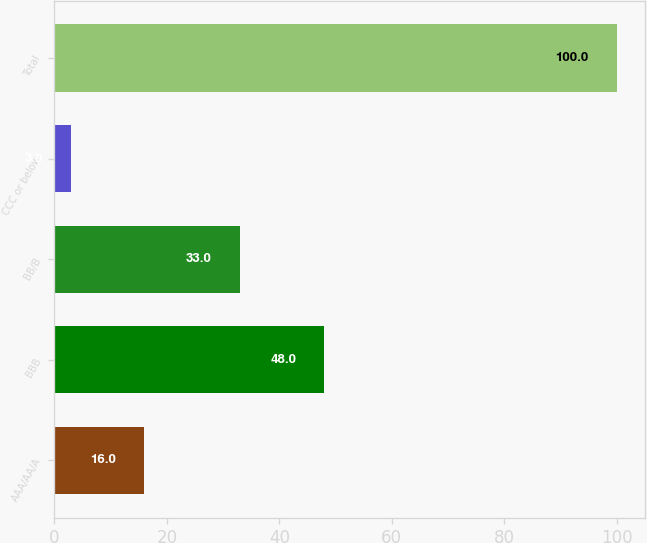Convert chart. <chart><loc_0><loc_0><loc_500><loc_500><bar_chart><fcel>AAA/AA/A<fcel>BBB<fcel>BB/B<fcel>CCC or below<fcel>Total<nl><fcel>16<fcel>48<fcel>33<fcel>3<fcel>100<nl></chart> 